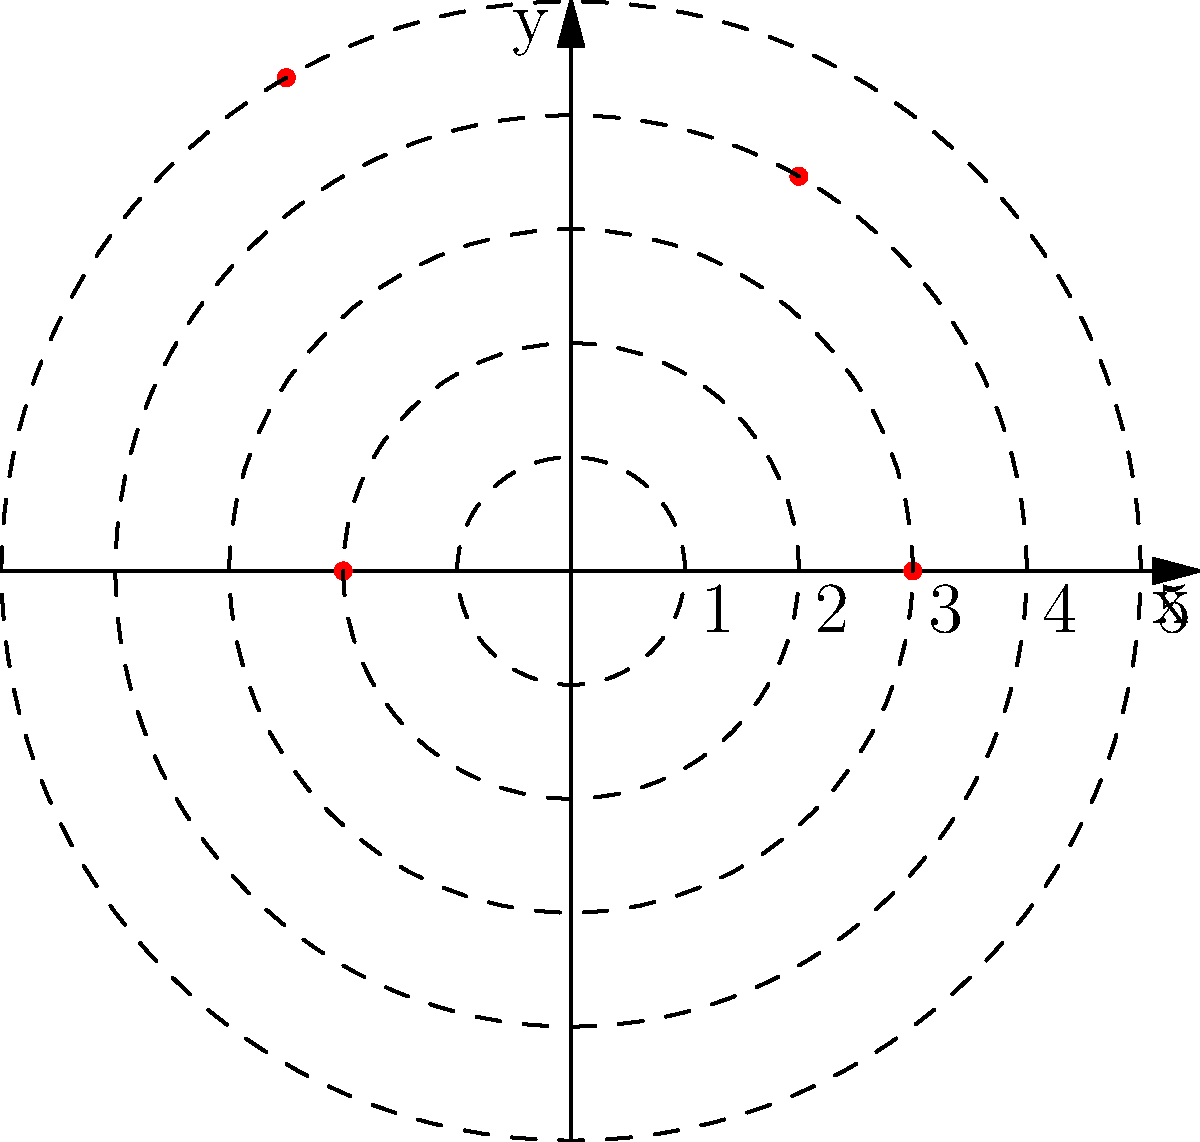As a Slovenian diplomat proud of your country's UNESCO World Heritage Sites, you're tasked with plotting their locations using polar coordinates. The graph shows four sites (A, B, C, and D) represented by red dots. Which site corresponds to the coordinates $(r, \theta) = (5, \frac{2\pi}{3})$? To solve this problem, let's follow these steps:

1) Recall that polar coordinates are represented as $(r, \theta)$, where:
   - $r$ is the distance from the origin
   - $\theta$ is the angle from the positive x-axis (measured counterclockwise)

2) We're looking for the point with $r = 5$ and $\theta = \frac{2\pi}{3}$

3) $r = 5$ means the point is on the outermost circle

4) $\theta = \frac{2\pi}{3}$ is equivalent to 120°, which is in the second quadrant

5) Looking at the graph:
   - Point A is on the x-axis ($\theta = 0$)
   - Point B is at 60° ($\theta = \frac{\pi}{3}$)
   - Point C is at 120° ($\theta = \frac{2\pi}{3}$) and on the outermost circle
   - Point D is on the negative x-axis ($\theta = \pi$)

6) Therefore, the point that matches our coordinates is C

This exercise demonstrates how polar coordinates can be used to precisely locate important cultural sites, showcasing Slovenia's rich heritage on an international scale.
Answer: C 